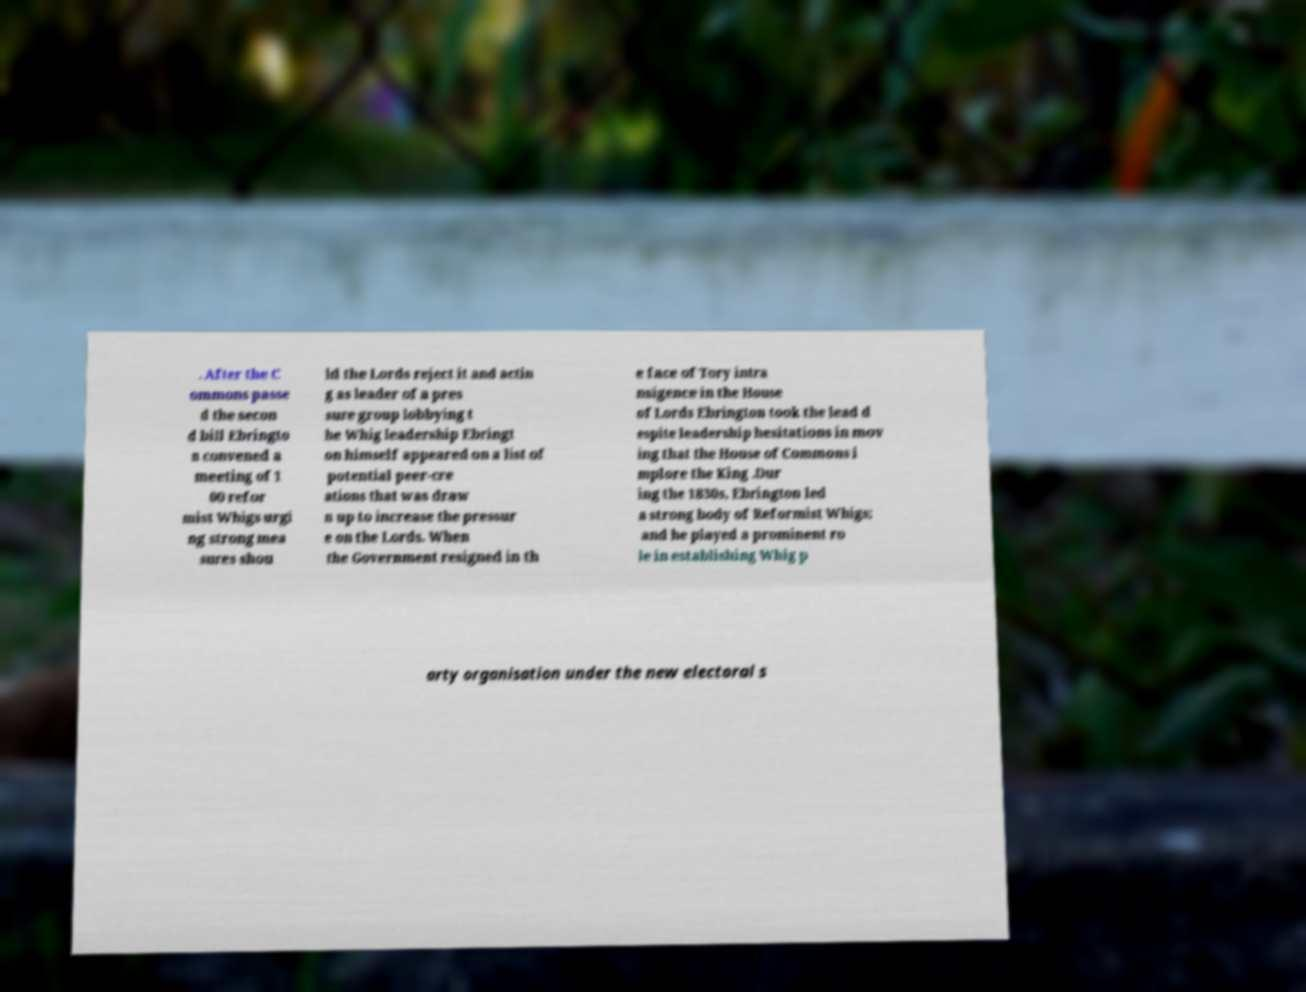What messages or text are displayed in this image? I need them in a readable, typed format. . After the C ommons passe d the secon d bill Ebringto n convened a meeting of 1 00 refor mist Whigs urgi ng strong mea sures shou ld the Lords reject it and actin g as leader of a pres sure group lobbying t he Whig leadership Ebringt on himself appeared on a list of potential peer-cre ations that was draw n up to increase the pressur e on the Lords. When the Government resigned in th e face of Tory intra nsigence in the House of Lords Ebrington took the lead d espite leadership hesitations in mov ing that the House of Commons i mplore the King .Dur ing the 1830s, Ebrington led a strong body of Reformist Whigs; and he played a prominent ro le in establishing Whig p arty organisation under the new electoral s 